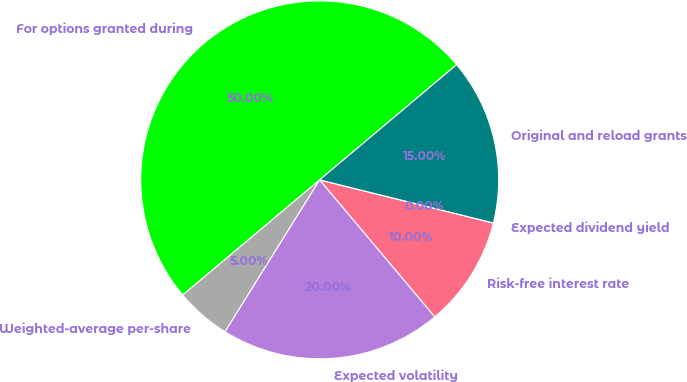Convert chart. <chart><loc_0><loc_0><loc_500><loc_500><pie_chart><fcel>For options granted during<fcel>Weighted-average per-share<fcel>Expected volatility<fcel>Risk-free interest rate<fcel>Expected dividend yield<fcel>Original and reload grants<nl><fcel>50.0%<fcel>5.0%<fcel>20.0%<fcel>10.0%<fcel>0.0%<fcel>15.0%<nl></chart> 